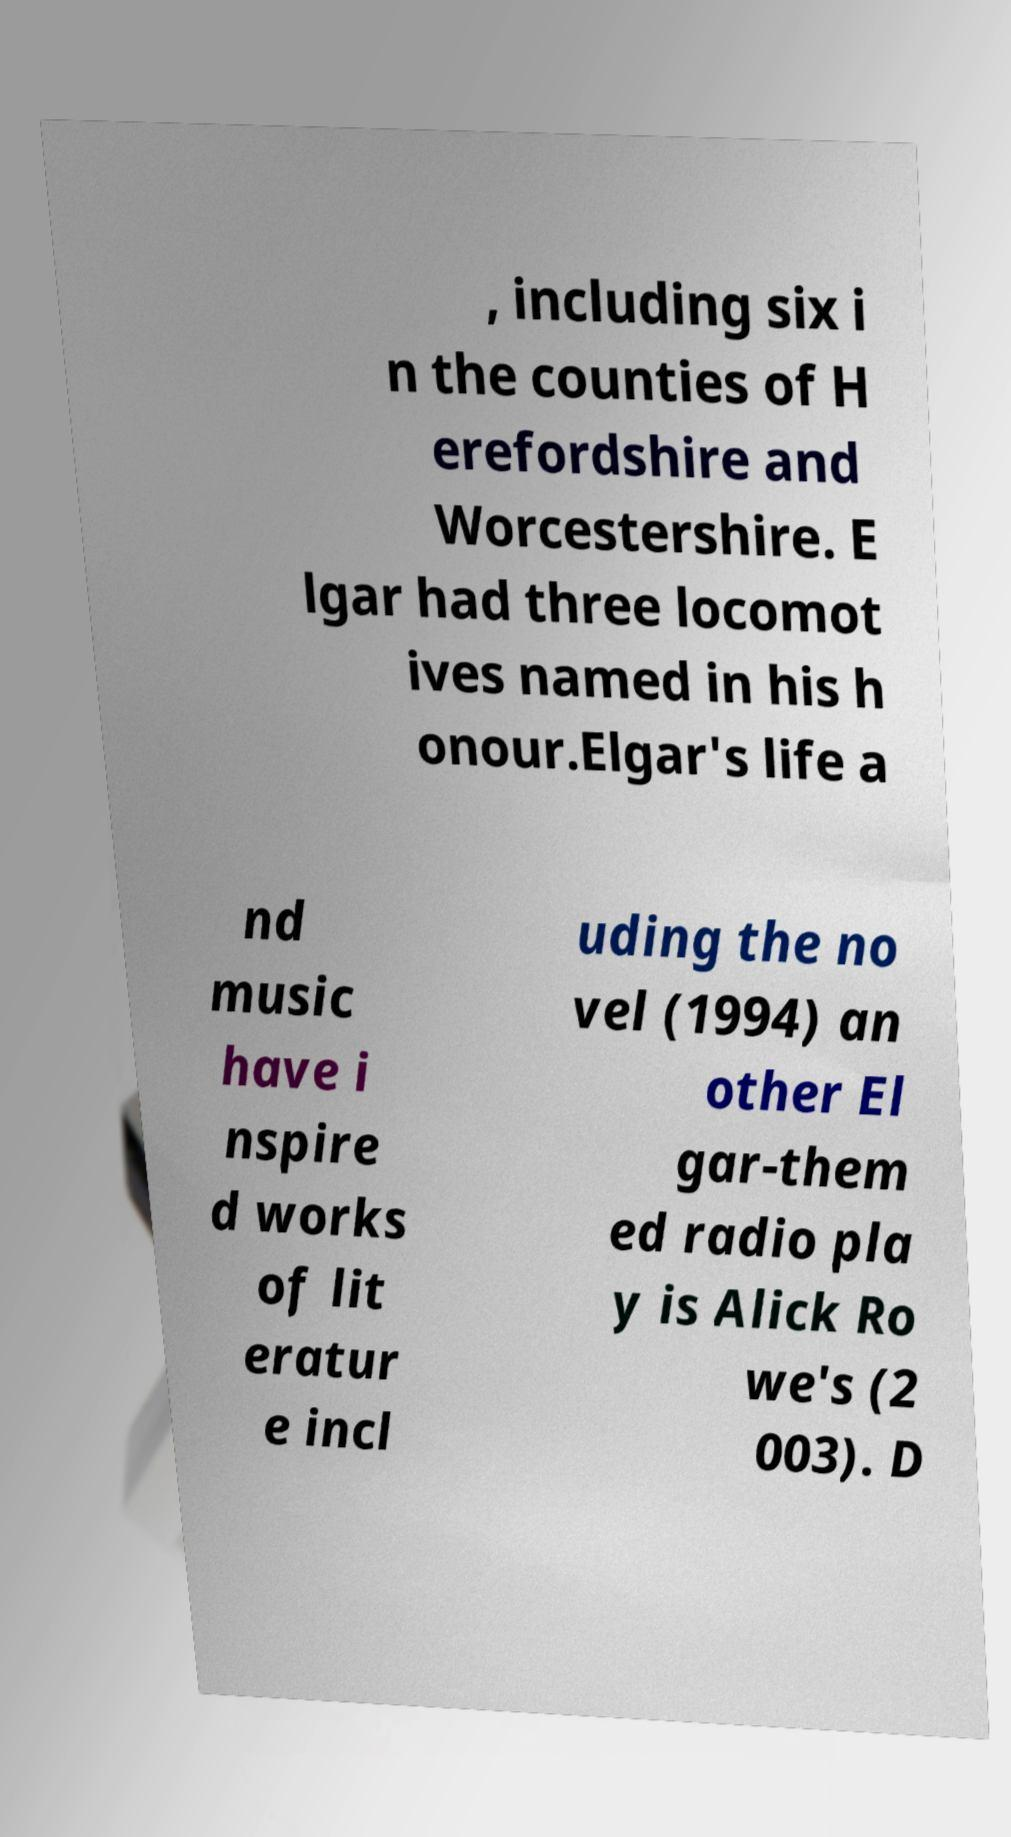Please read and relay the text visible in this image. What does it say? , including six i n the counties of H erefordshire and Worcestershire. E lgar had three locomot ives named in his h onour.Elgar's life a nd music have i nspire d works of lit eratur e incl uding the no vel (1994) an other El gar-them ed radio pla y is Alick Ro we's (2 003). D 